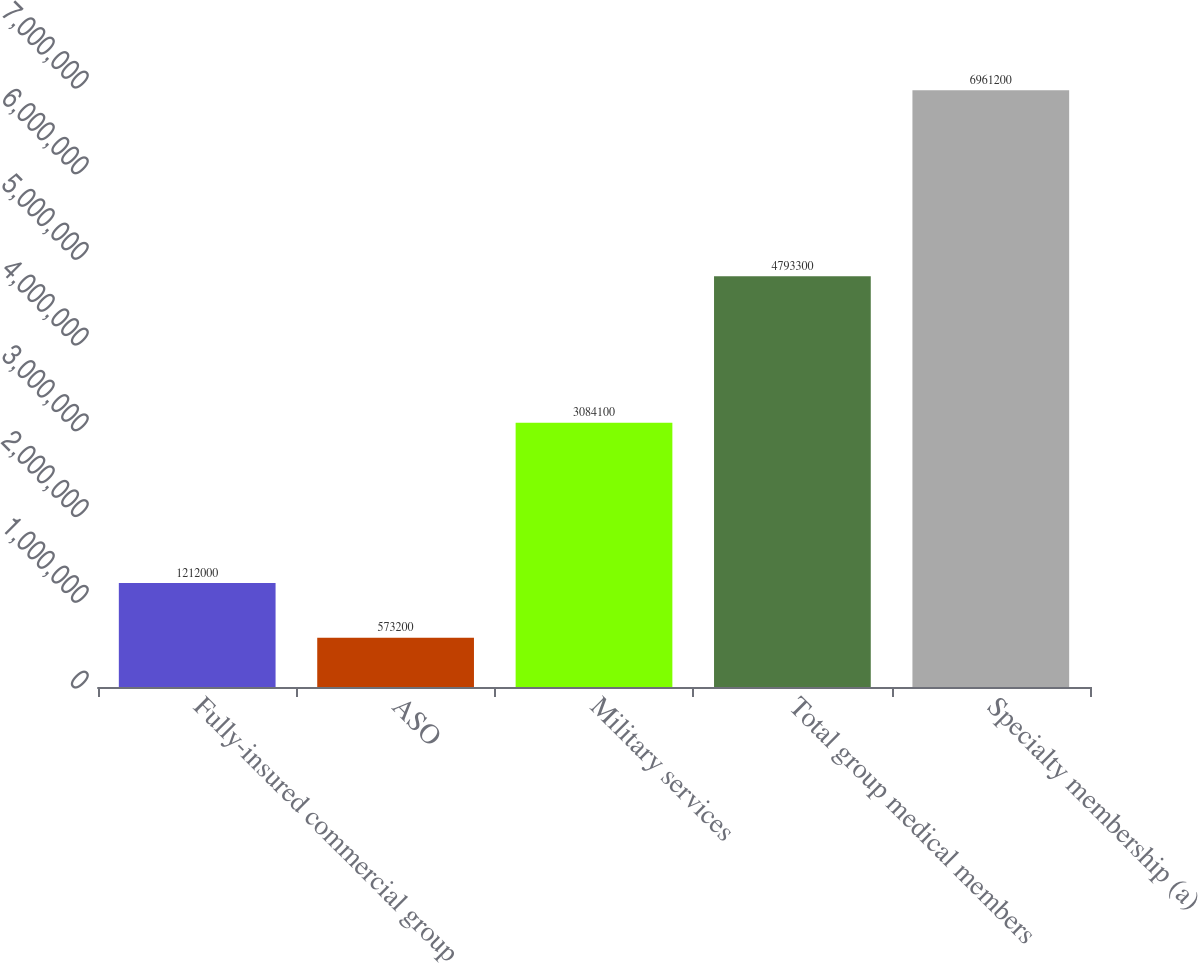Convert chart. <chart><loc_0><loc_0><loc_500><loc_500><bar_chart><fcel>Fully-insured commercial group<fcel>ASO<fcel>Military services<fcel>Total group medical members<fcel>Specialty membership (a)<nl><fcel>1.212e+06<fcel>573200<fcel>3.0841e+06<fcel>4.7933e+06<fcel>6.9612e+06<nl></chart> 